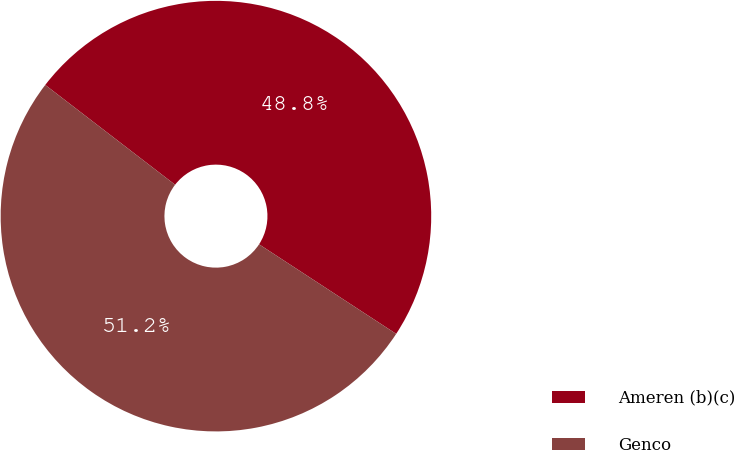Convert chart. <chart><loc_0><loc_0><loc_500><loc_500><pie_chart><fcel>Ameren (b)(c)<fcel>Genco<nl><fcel>48.78%<fcel>51.22%<nl></chart> 